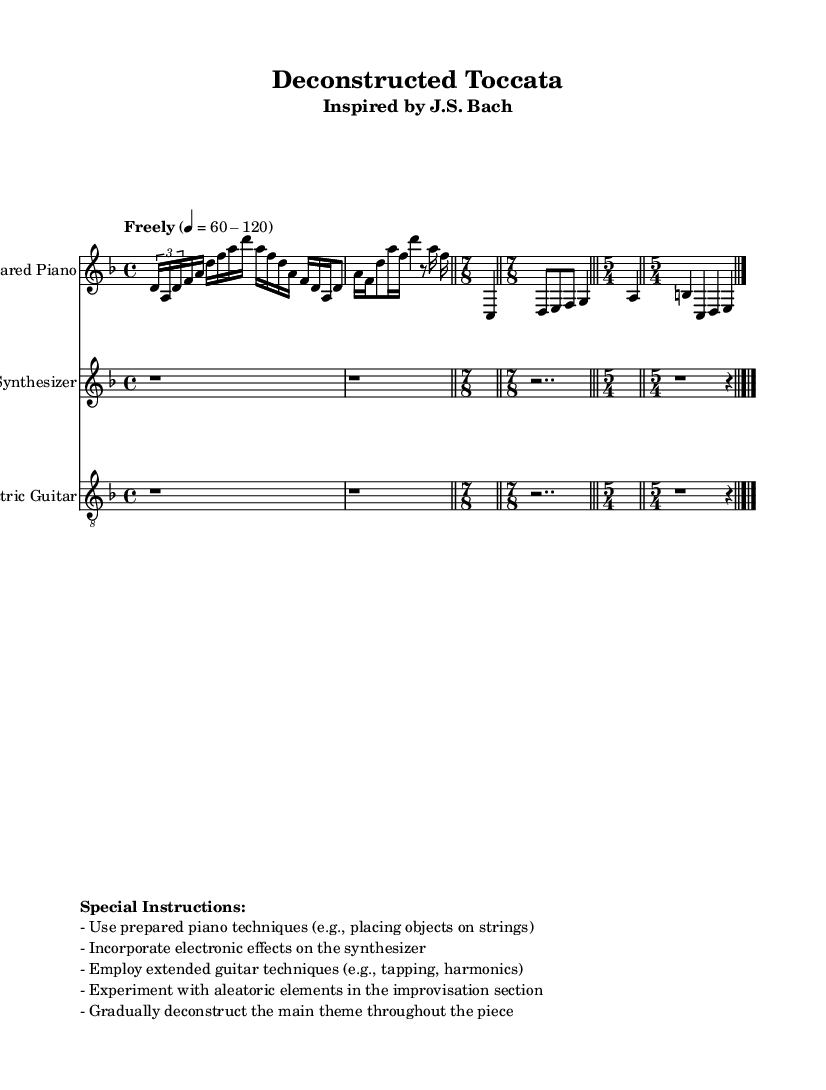What is the key signature of this music? The key signature is D minor, which consists of one flat (B flat). This is identifiable at the beginning of the staff where the key signature symbols are placed.
Answer: D minor What is the first time signature used in the piece? The first time signature shown is 4/4, which indicates four beats in a measure and that the quarter note gets one beat. This is seen immediately after the key signature at the start of the score.
Answer: 4/4 What tempo marking is indicated for this piece? The tempo marking is "Freely" with a metronome indication of 60-120 beats per minute. This indication suggests a flexible approach to tempo, allowing the performer to expressively interpret the rhythm within the specified range.
Answer: Freely 60-120 Which instruments are used in the score? The three instruments in the score are Prepared Piano, Synthesizer, and Electric Guitar. Each instrument has its own staff and is labeled at the beginning, providing clarity on which parts correspond to which instrument.
Answer: Prepared Piano, Synthesizer, Electric Guitar How many measures are in the section indicated with a time signature of 5/4? There are two measures indicated in the section with the time signature of 5/4, as shown by the notation which clearly displays bar lines separating the measures, confirming a total of two separate units of five beats.
Answer: 2 measures What is a specific performance instruction for the Prepared Piano? A specific instruction for the Prepared Piano is to use prepared piano techniques, such as placing objects on strings, which is mentioned in the special instructions provided in the score. This indicates an avant-garde approach to interpreting traditional piano sounds.
Answer: Use prepared piano techniques 